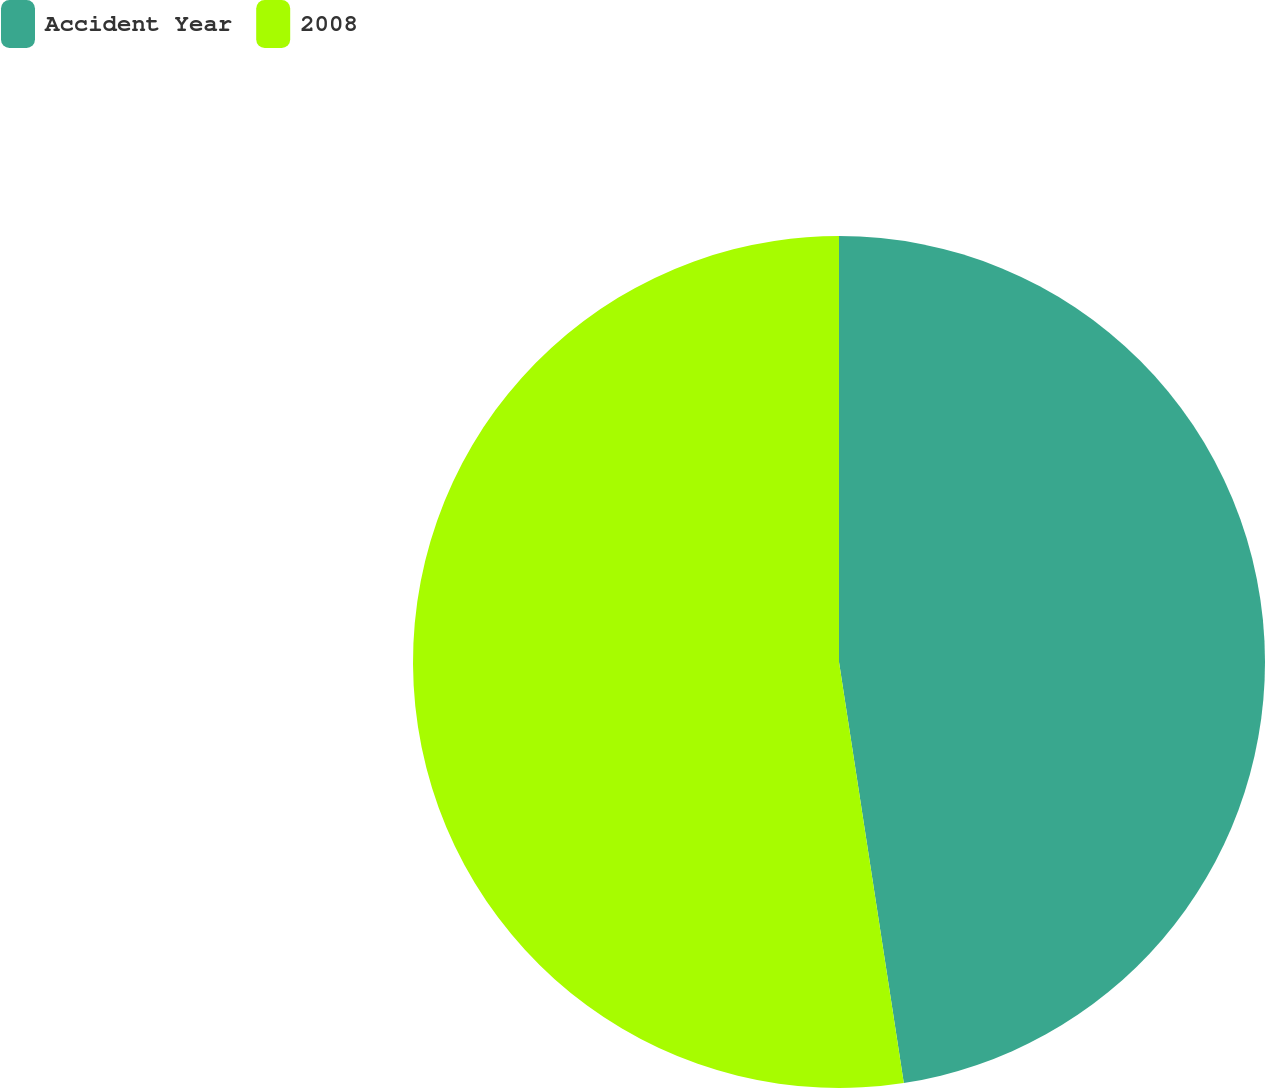Convert chart. <chart><loc_0><loc_0><loc_500><loc_500><pie_chart><fcel>Accident Year<fcel>2008<nl><fcel>47.57%<fcel>52.43%<nl></chart> 